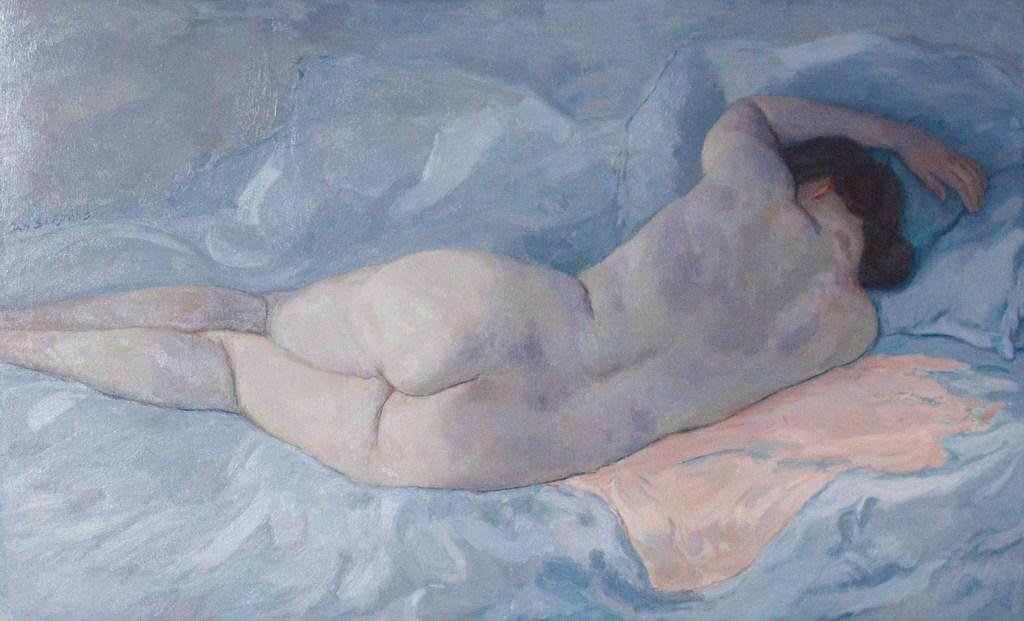What is the main subject in the center of the image? There is a painting in the center of the image. Can you describe the location of the painting in the image? The painting is in the center of the image. How many geese are flying towards the north in the image? There are no geese or any indication of direction in the image; it only features a painting. 